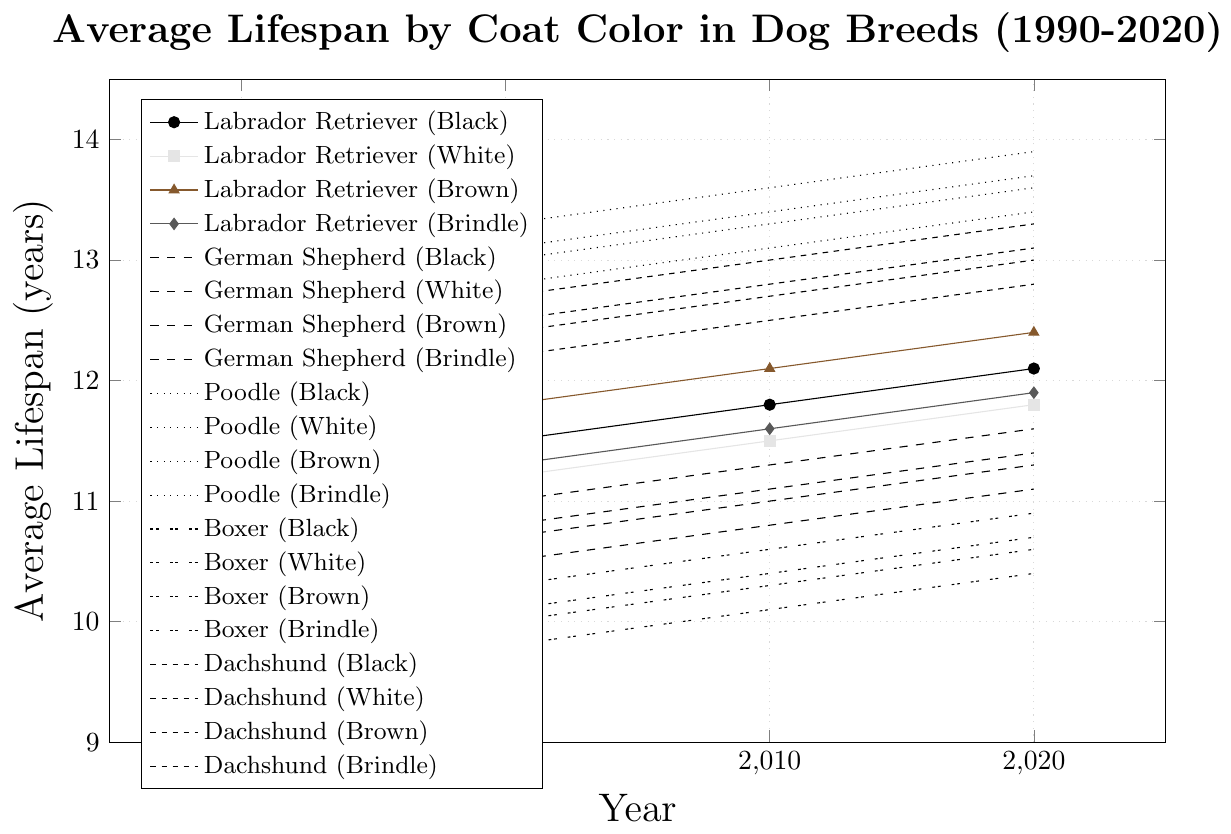Which breed and coat color has the longest average lifespan in 2020? Look at the 2020 data, find the breed and coat color with the highest lifespan. Poodle with Brown coat has the highest lifespan at 13.9 years.
Answer: Poodle (Brown) What was the increase in average lifespan for Black Labradors from 1990 to 2020? Subtract the 1990 lifespan of Black Labradors from the 2020 lifespan. (12.1 - 11.2 = 0.9 years)
Answer: 0.9 years Which breed shows the smallest lifespan difference between black and white coat colors in 2020? Calculate the difference between black and white coat colors for each breed in 2020. Labrador Retriever: 0.3, German Shepherd: 0.3, Poodle: 0.3, Boxer: 0.3, Dachshund: 0.3. All have the same 0.3 year difference.
Answer: All have the same How much did the average lifespan of Brown Boxers change between 1990 and 2020? Subtract the 1990 lifespan from the 2020 lifespan for Brown Boxers. (10.9 - 10.0 = 0.9 years)
Answer: 0.9 years Which breed had the lowest lifespan for White coat color in 1990? Look at the 1990 data and find the breed with the lowest lifespan for White coat color. Boxer had the lowest lifespan at 9.5 years.
Answer: Boxer What is the average lifespan of a Brindle Dachshund between 1990 and 2020? Sum the lifespans of Brindle Dachshunds from 1990, 2000, 2010, and 2020, then divide by 4. (12.1 + 12.4 + 12.7 + 13.0 = 50.2, 50.2 / 4 = 12.55 years)
Answer: 12.55 years Which coat color for Poodles shows the highest increase in average lifespan from 1990 to 2020? Calculate the increase for each color: Black (13.7 - 12.8 = 0.9), White (13.4 - 12.5 = 0.9), Brown (13.9 - 13.0 = 0.9), Brindle (13.6 - 12.7 = 0.9). All coat colors increase equally.
Answer: All the same Which breed has an average lifespan of 13.3 years in 2010 for Brown coat color? Find the breed that has a 13.3-year lifespan for Brown coat color in 2010. Poodle is the breed with 13.3 years.
Answer: Poodle What is the difference in lifespan for German Shepherds between Black and Brindle coat colors in 2000? Subtract the Brindle coat lifespan from the Black coat lifespan for 2000. (10.8 - 10.7 = 0.1 years)
Answer: 0.1 years Which breed and color combination shows the most consistent increase in lifespan from 1990 to 2020? Look for the combination with a consistent incremental increase. Poodle (Brown) shows consistent annual increases from 1990 (13.0), 2000 (13.3), 2010 (13.6), 2020 (13.9).
Answer: Poodle (Brown) 